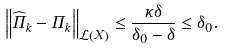<formula> <loc_0><loc_0><loc_500><loc_500>\left \| \widehat { \Pi } _ { k } - \Pi _ { k } \right \| _ { \mathcal { L } \left ( X \right ) } \leq \frac { \kappa \delta } { \delta _ { 0 } - \delta } \leq \delta _ { 0 } .</formula> 